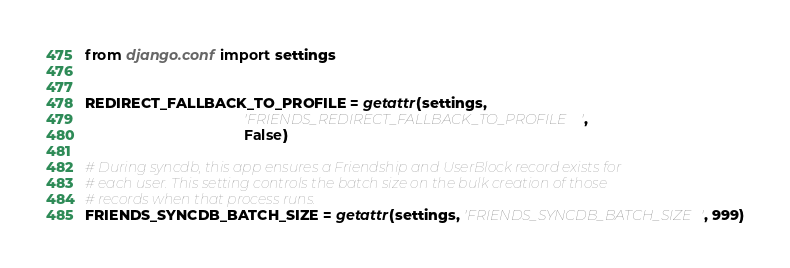<code> <loc_0><loc_0><loc_500><loc_500><_Python_>from django.conf import settings


REDIRECT_FALLBACK_TO_PROFILE = getattr(settings,
                                       'FRIENDS_REDIRECT_FALLBACK_TO_PROFILE',
                                       False)

# During syncdb, this app ensures a Friendship and UserBlock record exists for
# each user. This setting controls the batch size on the bulk creation of those
# records when that process runs.
FRIENDS_SYNCDB_BATCH_SIZE = getattr(settings, 'FRIENDS_SYNCDB_BATCH_SIZE', 999)
</code> 